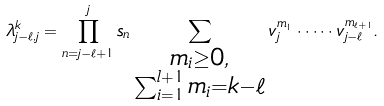<formula> <loc_0><loc_0><loc_500><loc_500>\lambda _ { j - \ell , j } ^ { k } = \prod _ { n = j - \ell + 1 } ^ { j } s _ { n } \sum _ { \substack { m _ { i } \geq 0 , \\ \sum _ { i = 1 } ^ { l + 1 } m _ { i } = k - \ell } } v _ { j } ^ { m _ { 1 } } \cdot \dots \cdot v _ { j - \ell } ^ { m _ { \ell + 1 } } .</formula> 